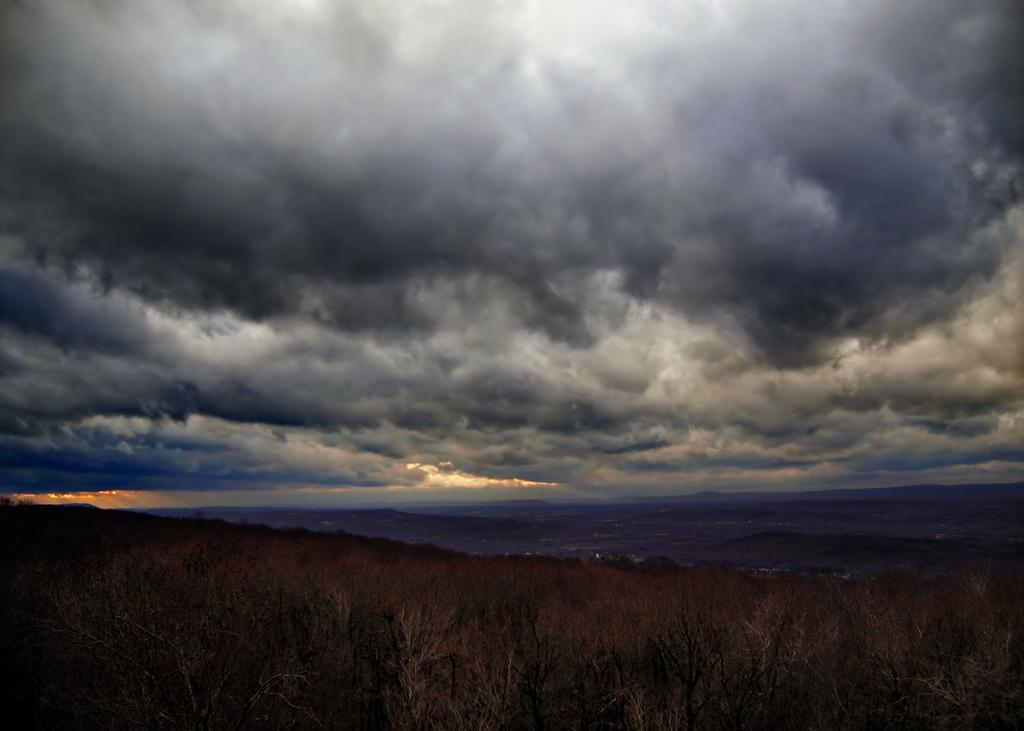What is the color of the sky in the image? The sky is dark in the image. What can be seen in the sky in the image? There are clouds visible in the image. What type of vegetation is present at the bottom of the image? Grass is present at the bottom of the image. What other natural elements are visible at the bottom of the image? Trees are visible at the bottom of the image. What type of rice is being harvested by the laborer in the image? There is no laborer or rice present in the image; it features a dark sky with clouds and vegetation at the bottom. 